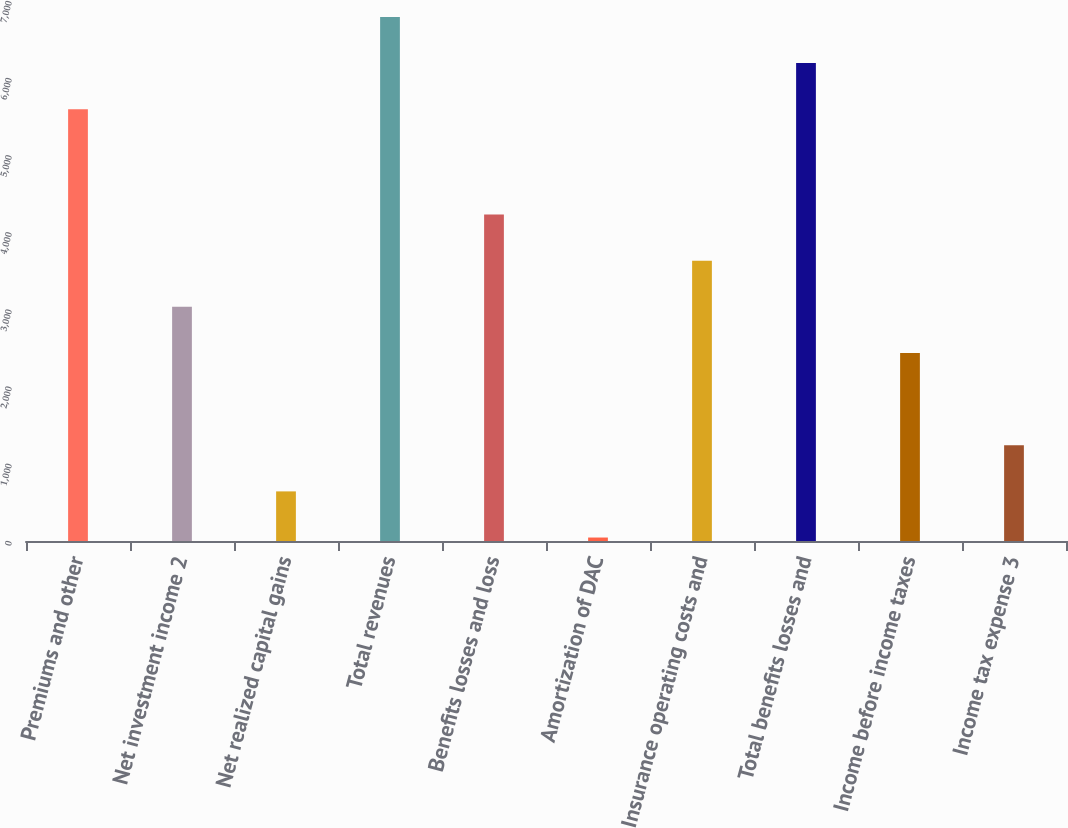Convert chart. <chart><loc_0><loc_0><loc_500><loc_500><bar_chart><fcel>Premiums and other<fcel>Net investment income 2<fcel>Net realized capital gains<fcel>Total revenues<fcel>Benefits losses and loss<fcel>Amortization of DAC<fcel>Insurance operating costs and<fcel>Total benefits losses and<fcel>Income before income taxes<fcel>Income tax expense 3<nl><fcel>5598<fcel>3035<fcel>643<fcel>6794<fcel>4231<fcel>45<fcel>3633<fcel>6196<fcel>2437<fcel>1241<nl></chart> 